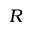Convert formula to latex. <formula><loc_0><loc_0><loc_500><loc_500>R</formula> 